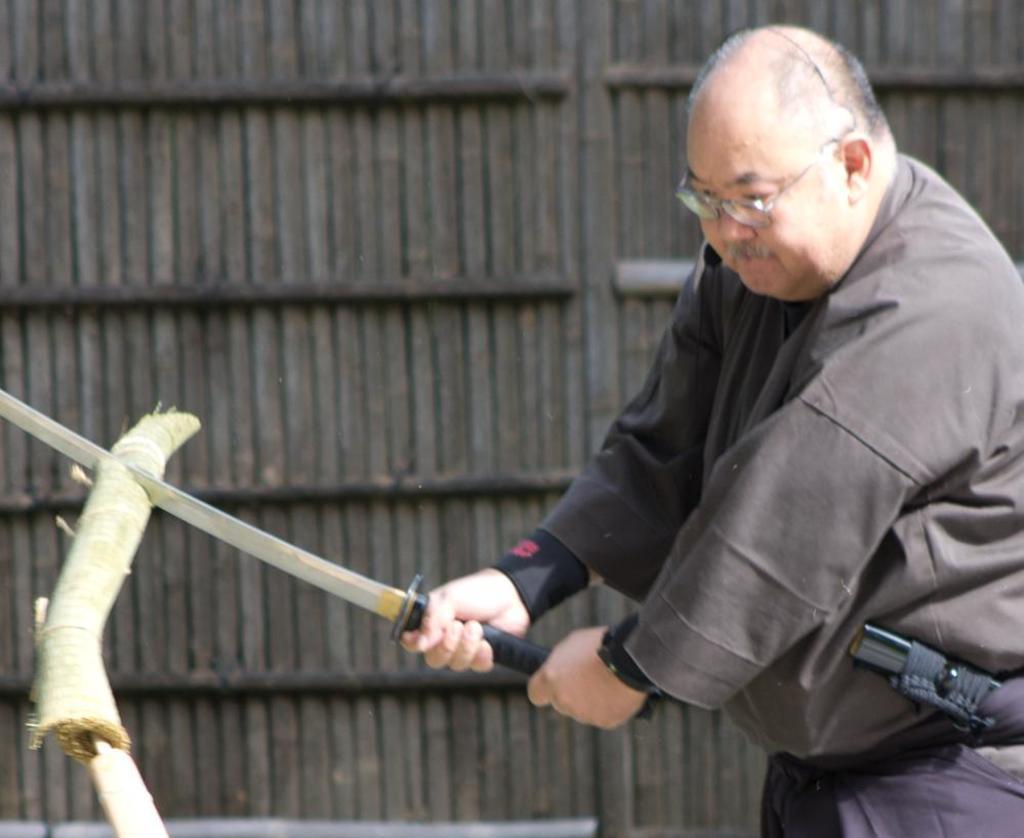How would you summarize this image in a sentence or two? In this image there is a person cutting wood with help of sword, beside him there is a wooden wall. 